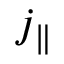Convert formula to latex. <formula><loc_0><loc_0><loc_500><loc_500>j _ { \| }</formula> 